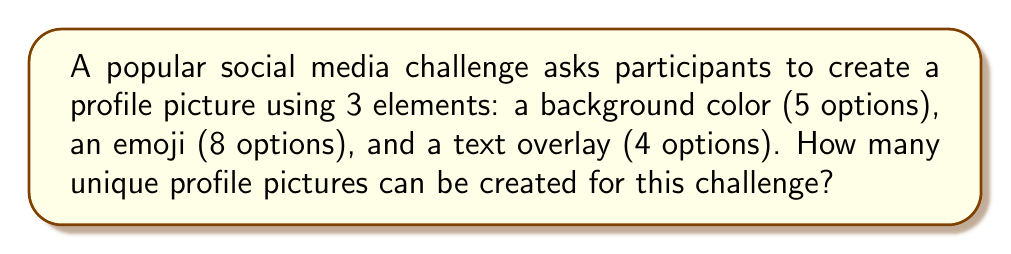Provide a solution to this math problem. Let's approach this step-by-step:

1) We have three independent choices to make:
   - Background color (5 options)
   - Emoji (8 options)
   - Text overlay (4 options)

2) This scenario follows the Multiplication Principle of Counting. When we have a series of independent choices, we multiply the number of options for each choice to get the total number of possible outcomes.

3) Mathematically, we can express this as:

   $$ \text{Total outcomes} = \text{Color options} \times \text{Emoji options} \times \text{Text options} $$

4) Substituting the numbers:

   $$ \text{Total outcomes} = 5 \times 8 \times 4 $$

5) Calculating:

   $$ \text{Total outcomes} = 160 $$

Therefore, there are 160 unique profile pictures that can be created for this social media challenge.
Answer: 160 unique profile pictures 